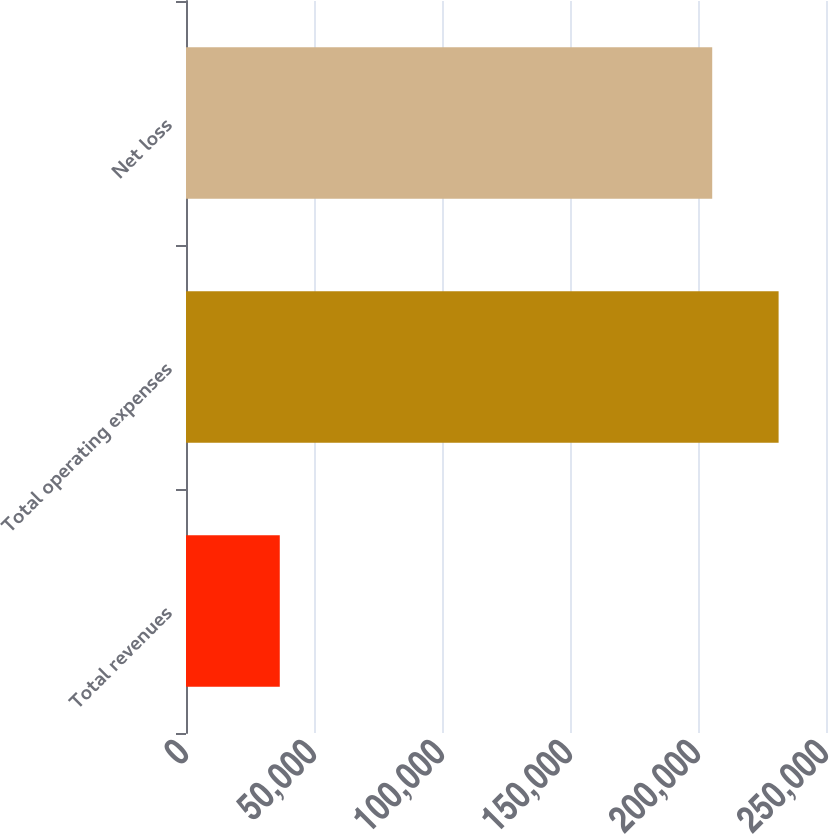Convert chart. <chart><loc_0><loc_0><loc_500><loc_500><bar_chart><fcel>Total revenues<fcel>Total operating expenses<fcel>Net loss<nl><fcel>36630<fcel>231486<fcel>205553<nl></chart> 